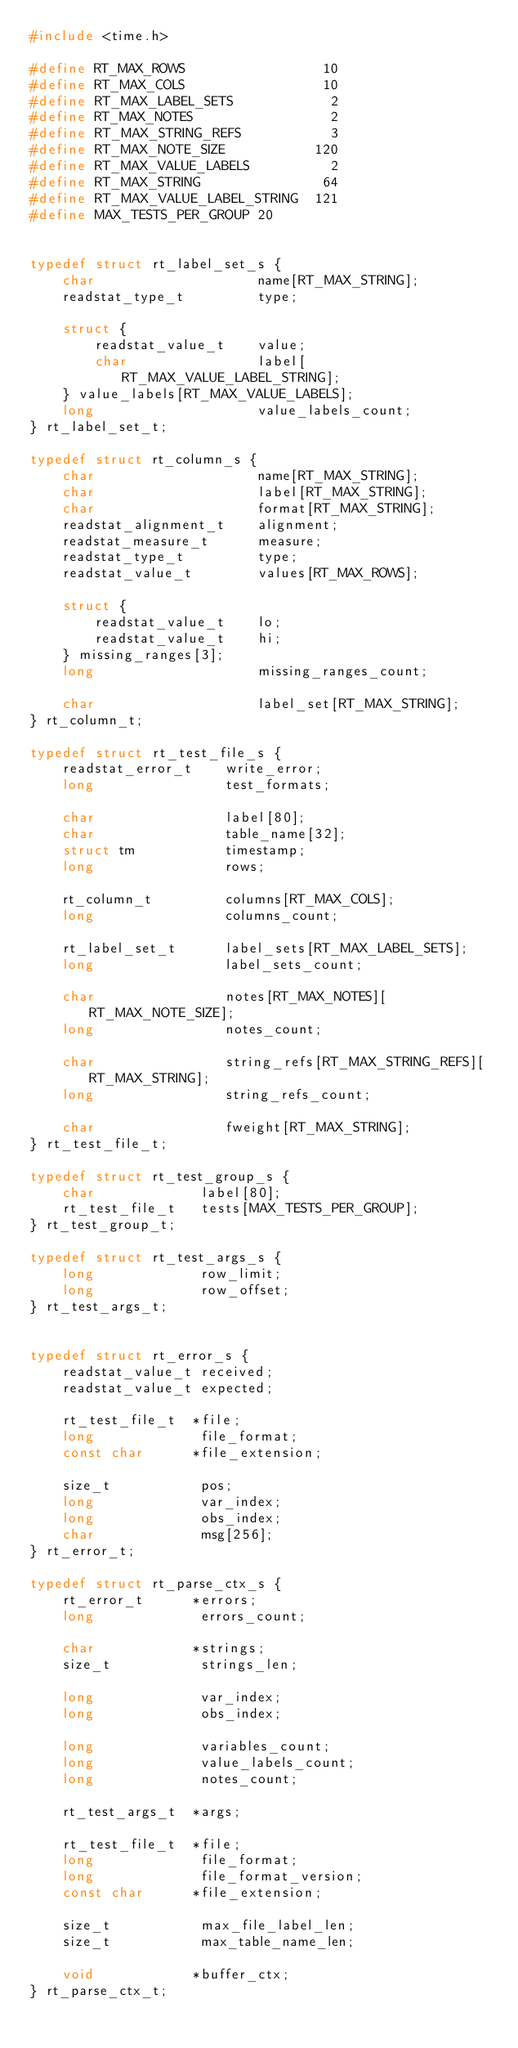<code> <loc_0><loc_0><loc_500><loc_500><_C_>#include <time.h>

#define RT_MAX_ROWS                 10
#define RT_MAX_COLS                 10
#define RT_MAX_LABEL_SETS            2
#define RT_MAX_NOTES                 2
#define RT_MAX_STRING_REFS           3
#define RT_MAX_NOTE_SIZE           120
#define RT_MAX_VALUE_LABELS          2
#define RT_MAX_STRING               64
#define RT_MAX_VALUE_LABEL_STRING  121
#define MAX_TESTS_PER_GROUP 20


typedef struct rt_label_set_s {
    char                    name[RT_MAX_STRING];
    readstat_type_t         type;

    struct {
        readstat_value_t    value;
        char                label[RT_MAX_VALUE_LABEL_STRING];
    } value_labels[RT_MAX_VALUE_LABELS];
    long                    value_labels_count;
} rt_label_set_t;

typedef struct rt_column_s {
    char                    name[RT_MAX_STRING];
    char                    label[RT_MAX_STRING];
    char                    format[RT_MAX_STRING];
    readstat_alignment_t    alignment;
    readstat_measure_t      measure;
    readstat_type_t         type;
    readstat_value_t        values[RT_MAX_ROWS];

    struct {
        readstat_value_t    lo;
        readstat_value_t    hi;
    } missing_ranges[3];
    long                    missing_ranges_count;

    char                    label_set[RT_MAX_STRING];
} rt_column_t;

typedef struct rt_test_file_s {
    readstat_error_t    write_error;
    long                test_formats;

    char                label[80];
    char                table_name[32];
    struct tm           timestamp;
    long                rows;

    rt_column_t         columns[RT_MAX_COLS];
    long                columns_count;

    rt_label_set_t      label_sets[RT_MAX_LABEL_SETS];
    long                label_sets_count;

    char                notes[RT_MAX_NOTES][RT_MAX_NOTE_SIZE];
    long                notes_count;

    char                string_refs[RT_MAX_STRING_REFS][RT_MAX_STRING];
    long                string_refs_count;

    char                fweight[RT_MAX_STRING];
} rt_test_file_t;

typedef struct rt_test_group_s {
    char             label[80];
    rt_test_file_t   tests[MAX_TESTS_PER_GROUP];
} rt_test_group_t;

typedef struct rt_test_args_s {
    long             row_limit;
    long             row_offset;    
} rt_test_args_t;


typedef struct rt_error_s {
    readstat_value_t received;
    readstat_value_t expected;

    rt_test_file_t  *file;
    long             file_format;
    const char      *file_extension;

    size_t           pos;
    long             var_index;
    long             obs_index;
    char             msg[256];
} rt_error_t;

typedef struct rt_parse_ctx_s {
    rt_error_t      *errors;
    long             errors_count;

    char            *strings;
    size_t           strings_len;

    long             var_index;
    long             obs_index;

    long             variables_count;
    long             value_labels_count;
    long             notes_count;

    rt_test_args_t  *args;

    rt_test_file_t  *file;
    long             file_format;
    long             file_format_version;
    const char      *file_extension;

    size_t           max_file_label_len;
    size_t           max_table_name_len;

    void            *buffer_ctx;
} rt_parse_ctx_t;
</code> 